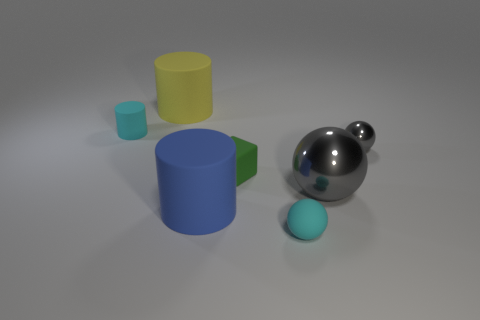Subtract all large yellow cylinders. How many cylinders are left? 2 Add 1 tiny cylinders. How many objects exist? 8 Subtract 1 spheres. How many spheres are left? 2 Subtract all cyan cylinders. How many cylinders are left? 2 Subtract 0 brown spheres. How many objects are left? 7 Subtract all blocks. How many objects are left? 6 Subtract all cyan cubes. Subtract all red spheres. How many cubes are left? 1 Subtract all gray cubes. How many gray balls are left? 2 Subtract all cyan matte objects. Subtract all tiny cyan balls. How many objects are left? 4 Add 1 blue matte cylinders. How many blue matte cylinders are left? 2 